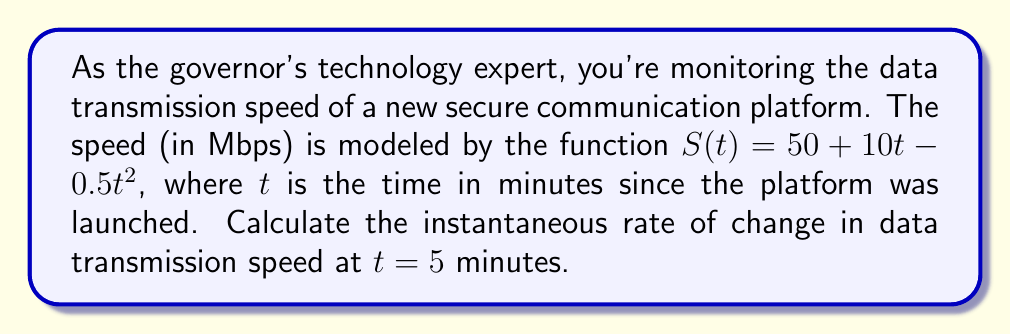Can you answer this question? To find the instantaneous rate of change in data transmission speed at $t = 5$ minutes, we need to calculate the derivative of the function $S(t)$ and evaluate it at $t = 5$.

1. Given function: $S(t) = 50 + 10t - 0.5t^2$

2. Calculate the derivative $S'(t)$:
   $$\begin{align}
   S'(t) &= \frac{d}{dt}(50 + 10t - 0.5t^2) \\
   &= 0 + 10 - 2(0.5)t \\
   &= 10 - t
   \end{align}$$

3. Evaluate $S'(t)$ at $t = 5$:
   $$\begin{align}
   S'(5) &= 10 - 5 \\
   &= 5
   \end{align}$$

The instantaneous rate of change at $t = 5$ minutes is 5 Mbps/minute. This positive value indicates that the data transmission speed is still increasing at this point, but at a slower rate than initially due to the negative quadratic term in the original function.
Answer: The instantaneous rate of change in data transmission speed at $t = 5$ minutes is 5 Mbps/minute. 